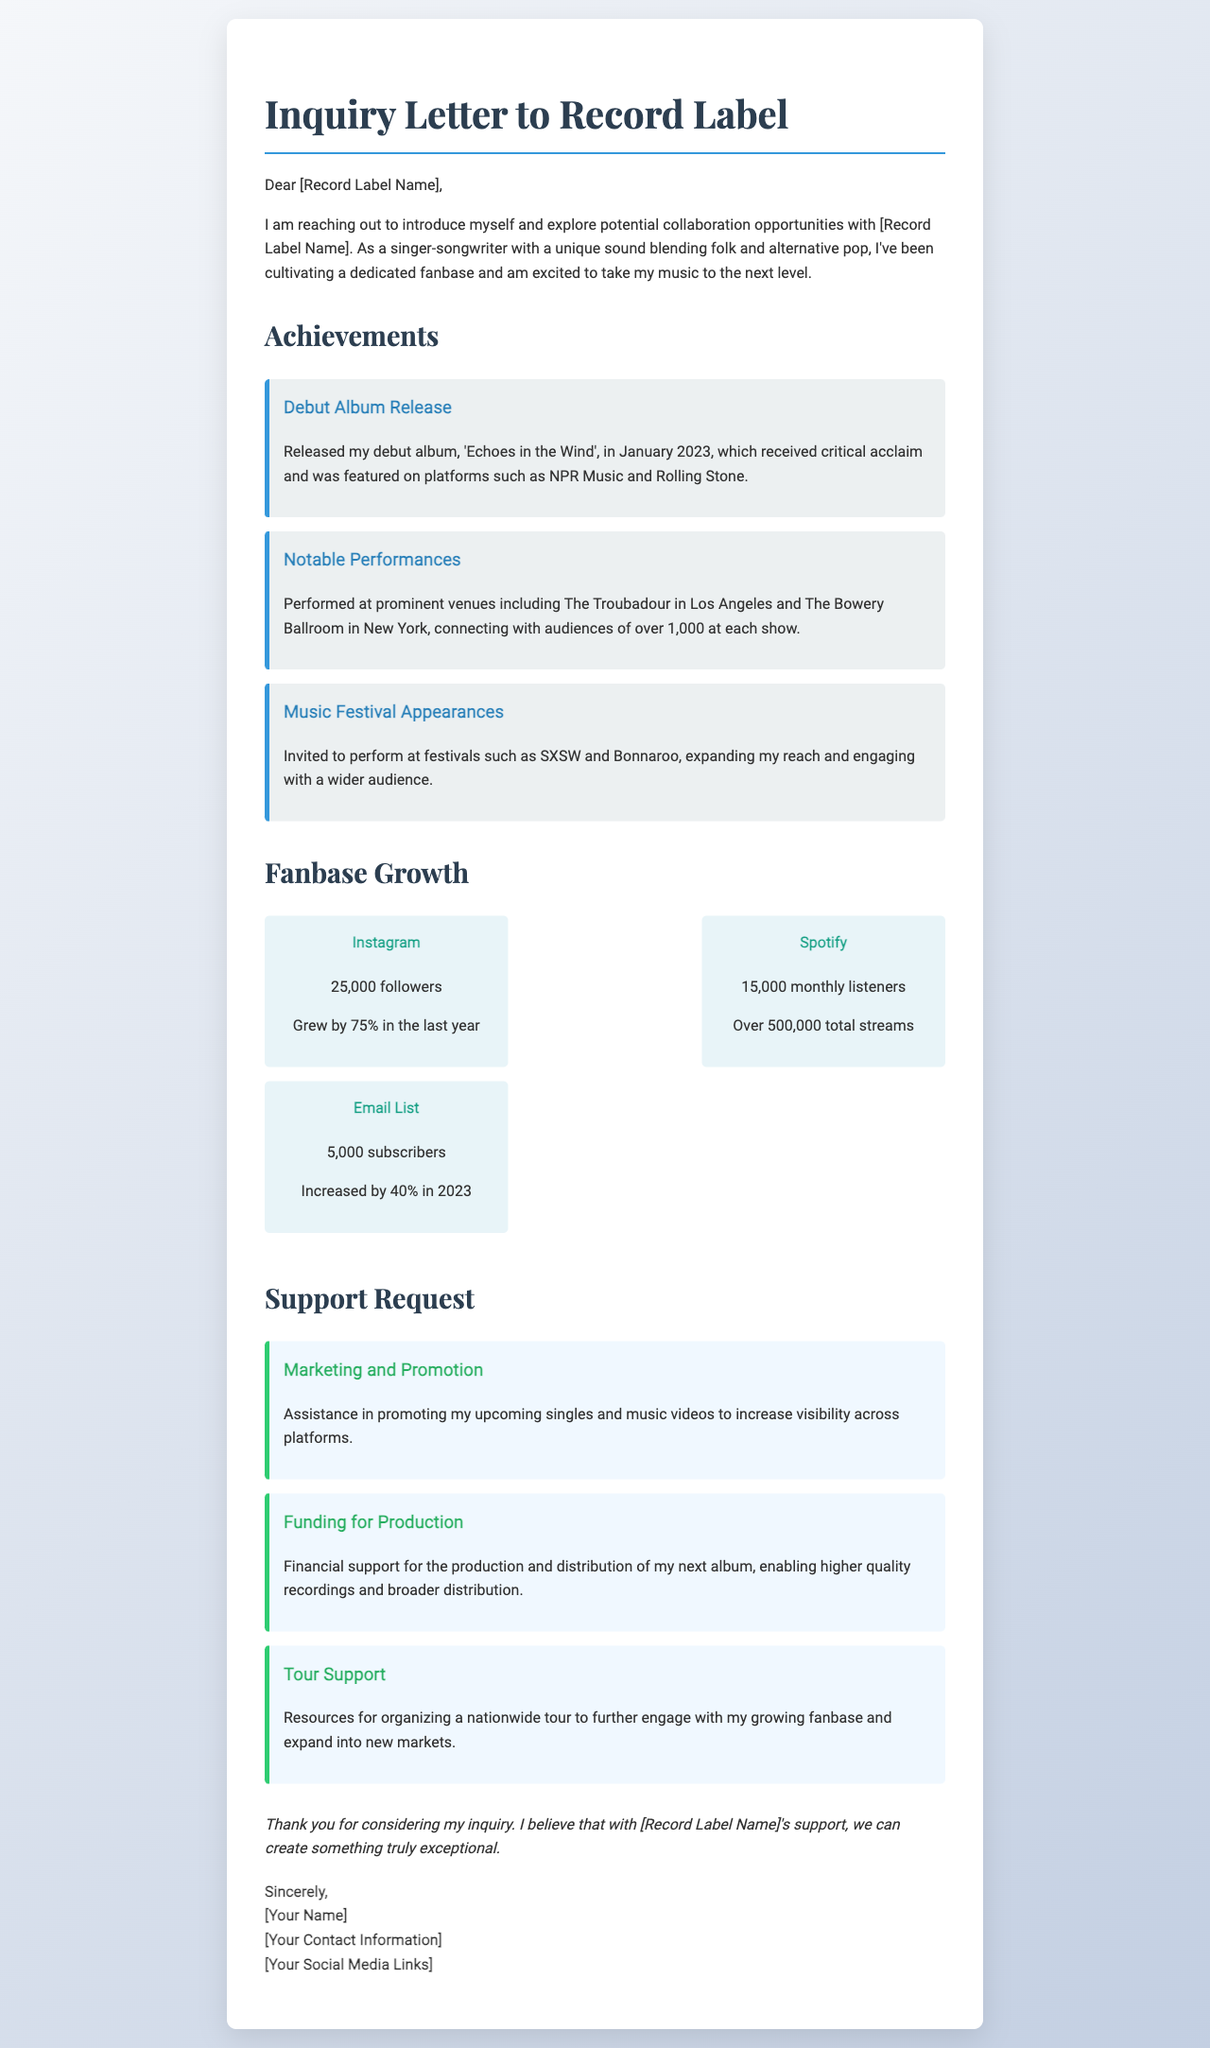What is the name of the debut album? The debut album is named 'Echoes in the Wind'.
Answer: 'Echoes in the Wind' What was the growth percentage of Instagram followers? The Instagram followers grew by 75% in the last year.
Answer: 75% Which notable venues did the artist perform at? The artist performed at The Troubadour in Los Angeles and The Bowery Ballroom in New York.
Answer: The Troubadour, The Bowery Ballroom How many monthly listeners does the artist have on Spotify? The artist has 15,000 monthly listeners on Spotify.
Answer: 15,000 What type of funding is being requested for the next album? The request is for financial support for the production and distribution of the next album.
Answer: Funding for Production What is the total number of email subscribers? The total number of email subscribers is 5,000.
Answer: 5,000 What is the purpose of the letter? The purpose of the letter is to explore potential collaboration opportunities with a record label.
Answer: Explore potential collaboration opportunities What festivals has the artist been invited to perform at? The artist has been invited to perform at SXSW and Bonnaroo.
Answer: SXSW, Bonnaroo 